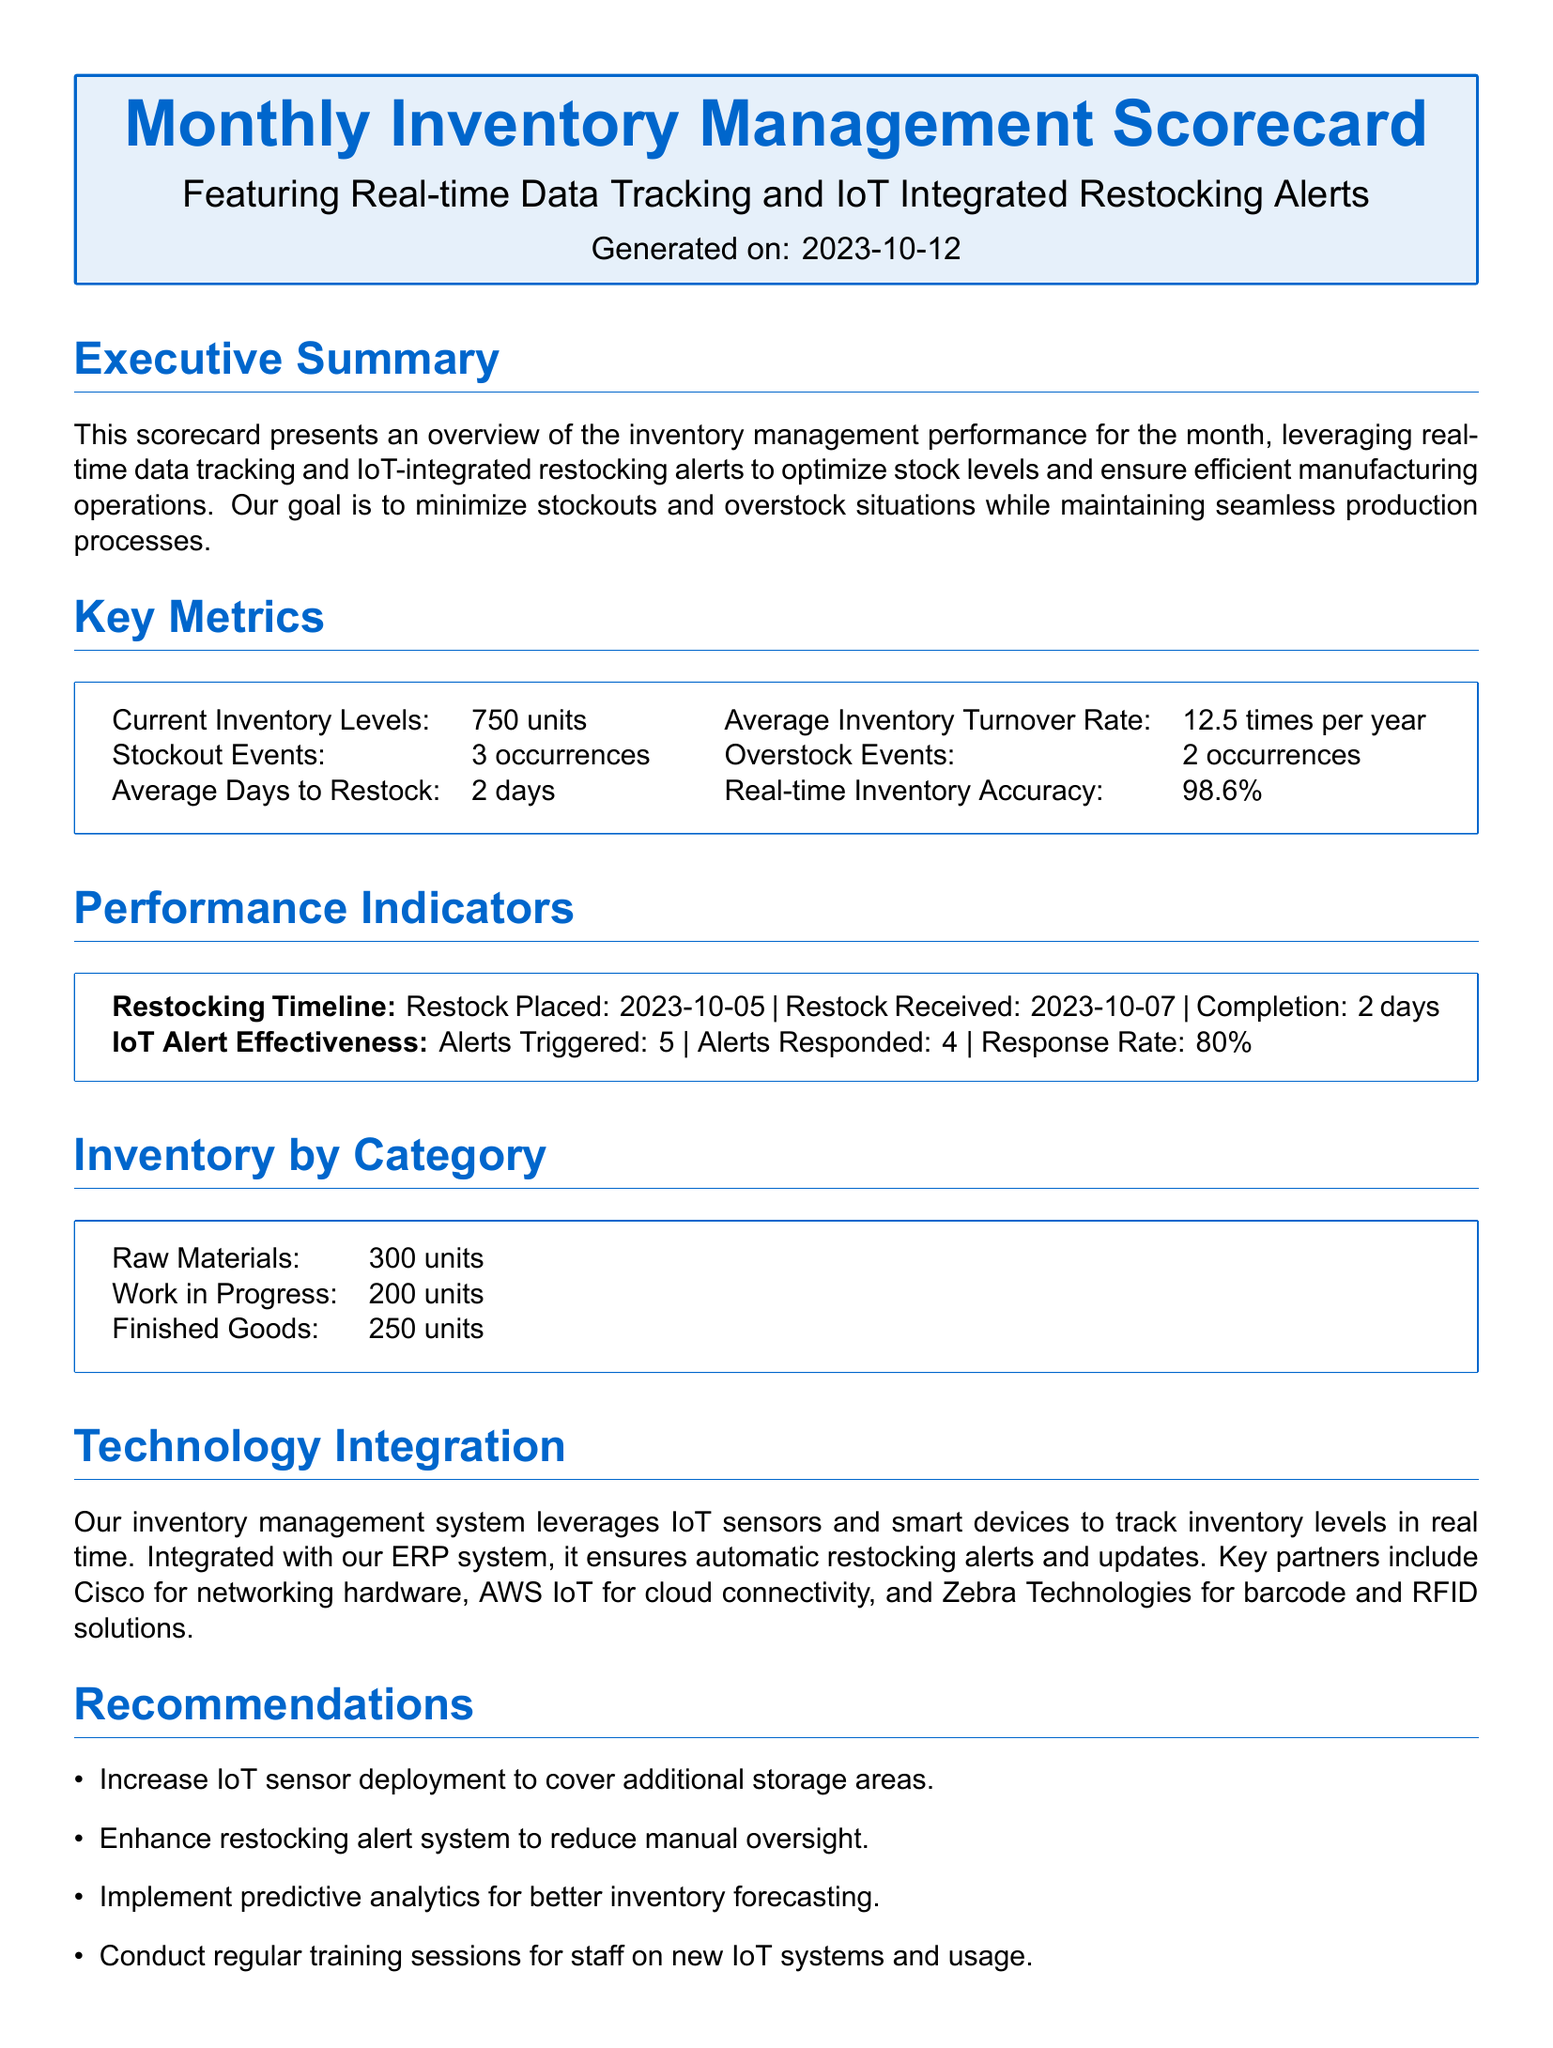What is the current inventory level? The current inventory level is stated in the key metrics section as 750 units.
Answer: 750 units How many stockout events occurred? The number of stockout events is provided in the key metrics section, which states there were 3 occurrences.
Answer: 3 occurrences What is the average days to restock? This figure can be found in the key metrics section, which indicates an average of 2 days to restock.
Answer: 2 days What was the response rate to IoT alerts? This information is contained in the performance indicators section, detailing a response rate of 80 percent.
Answer: 80% What integration partner is mentioned for cloud connectivity? The technology integration section lists AWS IoT as the partner for cloud connectivity.
Answer: AWS IoT What recommendation is made regarding IoT sensors? One of the recommendations suggests increasing IoT sensor deployment to cover additional storage areas.
Answer: Increase IoT sensor deployment How many categories of inventory are listed? The inventory by category section lists three categories, namely Raw Materials, Work in Progress, and Finished Goods.
Answer: Three categories When was the restock placed? The restock placed date is mentioned in the performance indicators section as October 5, 2023.
Answer: 2023-10-05 What is the average inventory turnover rate? This detail can be found in the key metrics section that states the average inventory turnover rate is 12.5 times per year.
Answer: 12.5 times per year 